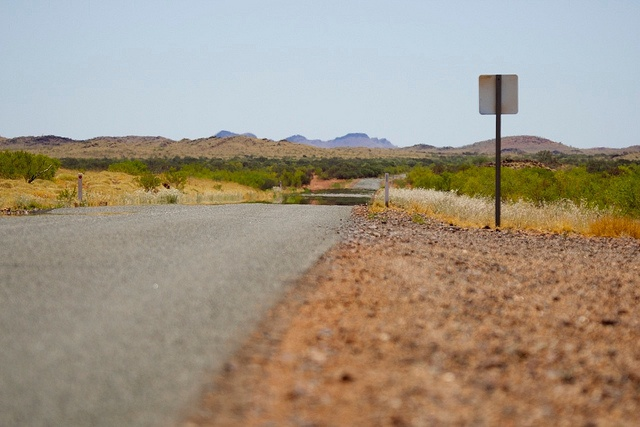Describe the objects in this image and their specific colors. I can see various objects in this image with different colors. 